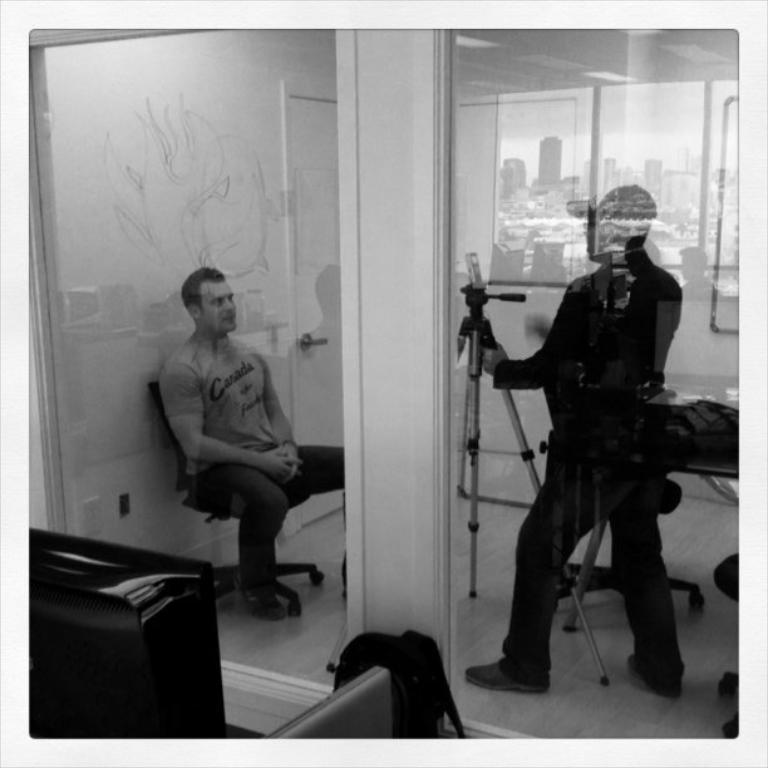How many people are in the image? There are two persons in the image. What are the positions of the two people in the image? One man is sitting on a chair, and the other man is standing. What can be seen at the bottom of the image? There is a bag at the bottom of the image. What is the color of the walls in the image? The walls are in white color. What type of locket is the man wearing in the image? There is no locket visible on either man in the image. How does the sun affect the lighting in the image? The provided facts do not mention the presence of the sun or any lighting conditions in the image. 